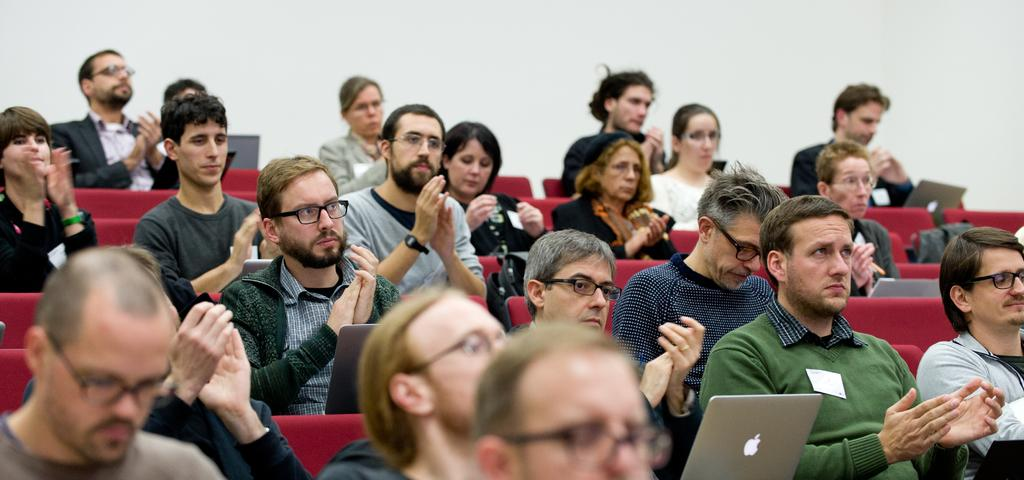What are the people in the image doing? There is a group of people sitting in the image. What is the person in front of the group doing? The person in front is using a laptop. What color are the chairs the people are sitting on? The chairs are green. What color is the background in the image? The background is white. How many dogs are sitting with the group of people in the image? There are no dogs present in the image; it only features a group of people sitting and a person using a laptop. 